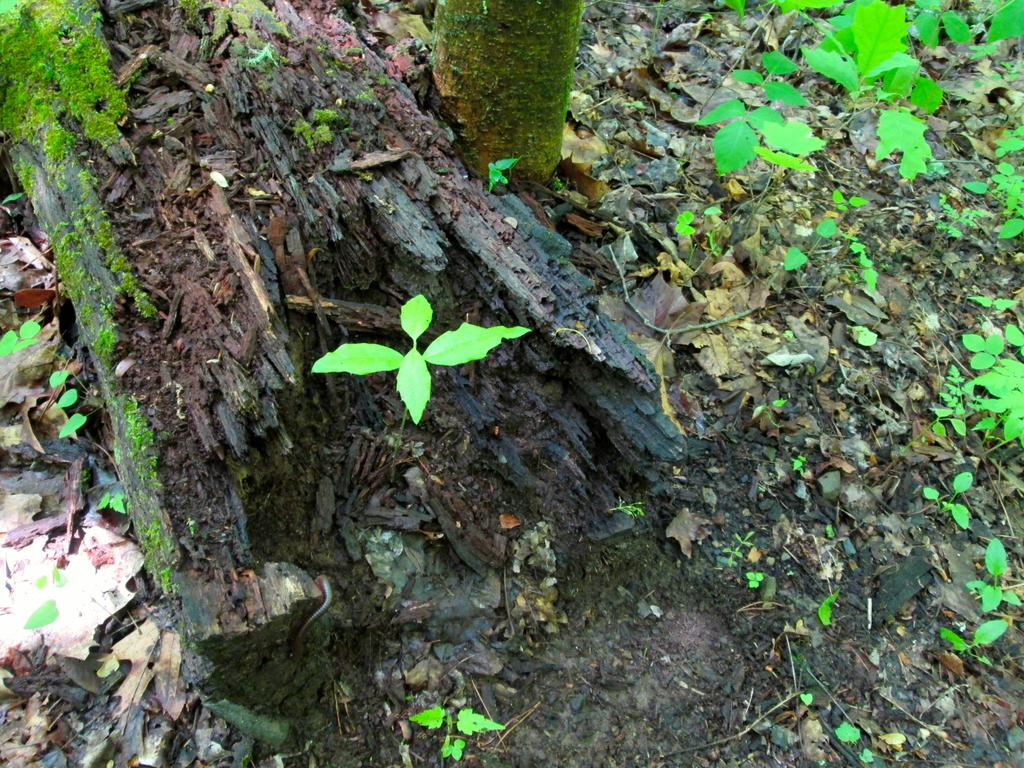What type of tree is depicted in the image? There is a cut down tree and a truncated tree in the image. What else can be seen in the image besides the trees? Small plants are present in the image, and leaves are on the ground. How does the pig interact with the cut down tree in the image? There is no pig present in the image, so it cannot interact with the cut down tree. 